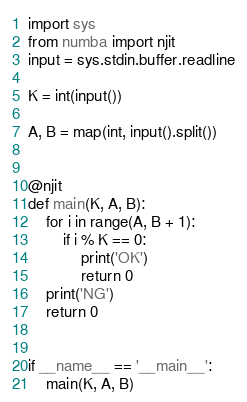Convert code to text. <code><loc_0><loc_0><loc_500><loc_500><_Python_>import sys
from numba import njit
input = sys.stdin.buffer.readline

K = int(input())

A, B = map(int, input().split())


@njit
def main(K, A, B):
    for i in range(A, B + 1):
        if i % K == 0:
            print('OK')
            return 0
    print('NG')
    return 0


if __name__ == '__main__':
    main(K, A, B)
</code> 